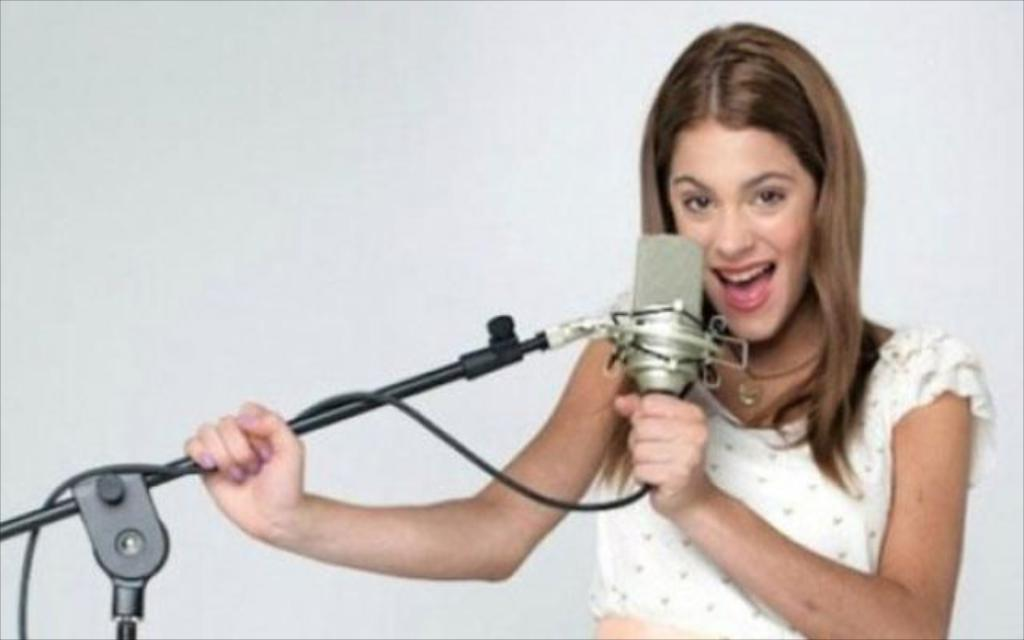Who is the main subject in the image? There is a woman in the image. What is the woman holding in the image? The woman is holding a microphone stand. What might the woman be doing with the microphone stand? It appears that the woman is singing a song. How many planes are visible in the image? There are no planes visible in the image. What type of cheese is being used as a prop in the image? There is no cheese present in the image. 